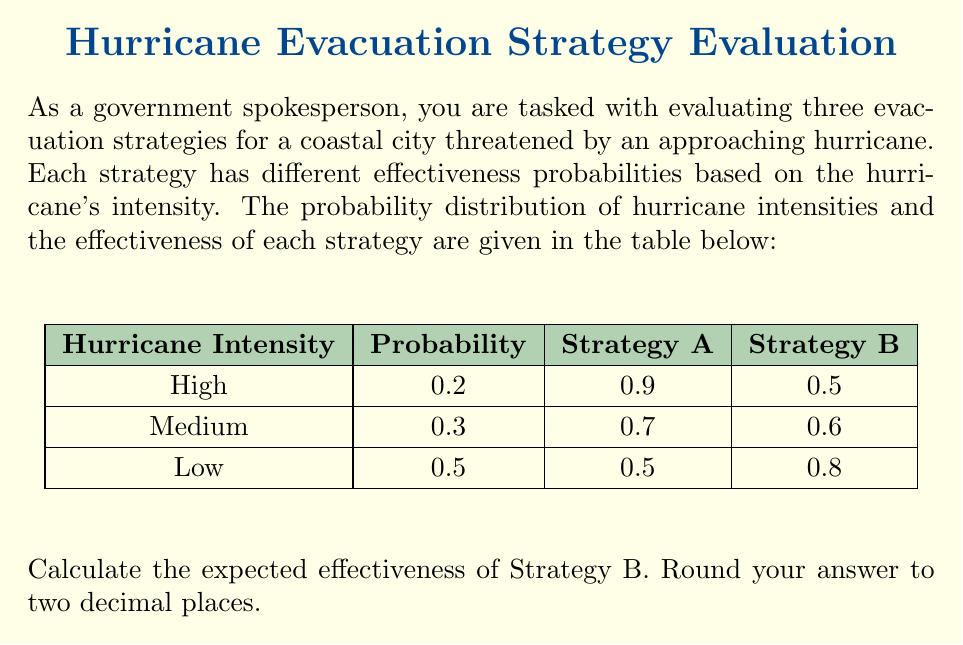Give your solution to this math problem. To calculate the expected effectiveness of Strategy B, we need to use the concept of expected value. The expected value is the sum of each possible outcome multiplied by its probability.

Let's break it down step by step:

1) First, we identify the probabilities of each hurricane intensity:
   - High intensity: $P(H) = 0.2$
   - Medium intensity: $P(M) = 0.3$
   - Low intensity: $P(L) = 0.5$

2) Next, we identify the effectiveness of Strategy B for each intensity:
   - High intensity: $E(H) = 0.5$
   - Medium intensity: $E(M) = 0.7$
   - Low intensity: $E(L) = 0.9$

3) Now, we calculate the expected effectiveness using the formula:

   $E(\text{Strategy B}) = P(H) \cdot E(H) + P(M) \cdot E(M) + P(L) \cdot E(L)$

4) Let's substitute the values:

   $E(\text{Strategy B}) = (0.2 \cdot 0.5) + (0.3 \cdot 0.7) + (0.5 \cdot 0.9)$

5) Calculate each term:
   
   $E(\text{Strategy B}) = 0.1 + 0.21 + 0.45$

6) Sum up the terms:

   $E(\text{Strategy B}) = 0.76$

7) Rounding to two decimal places:

   $E(\text{Strategy B}) \approx 0.76$

Therefore, the expected effectiveness of Strategy B is 0.76 or 76%.
Answer: 0.76 